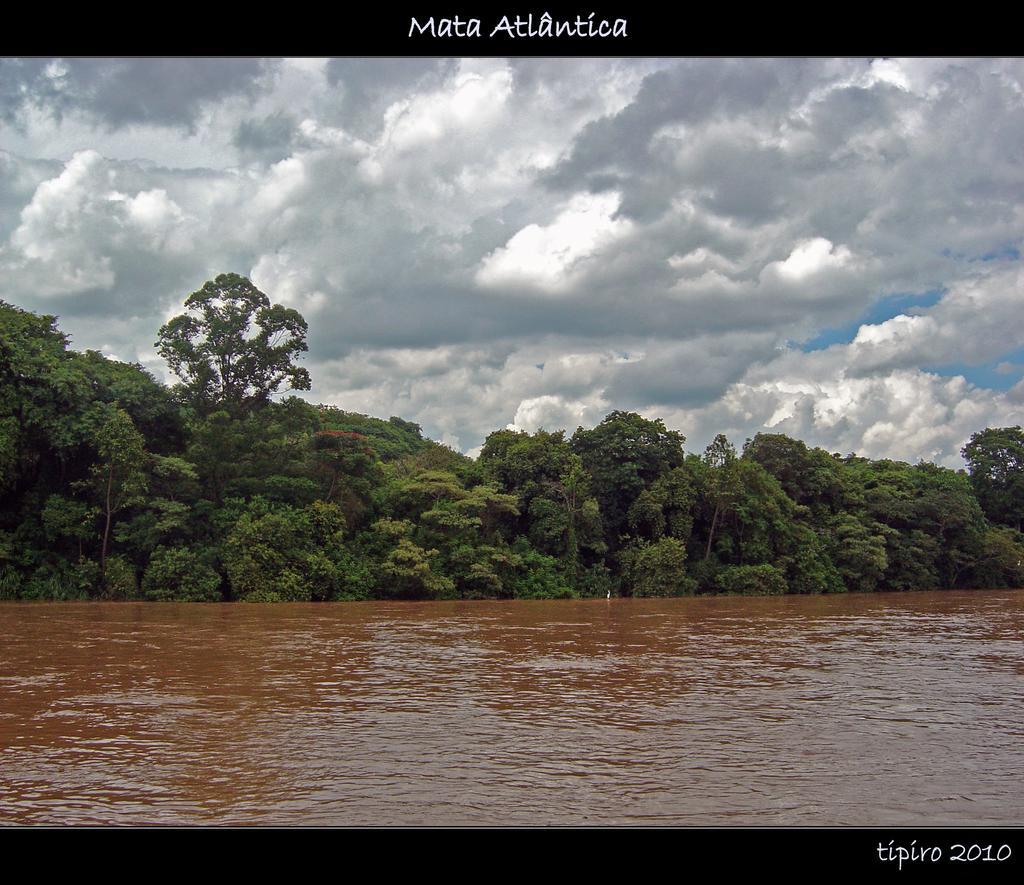Please provide a concise description of this image. In this picture we can see one lake, beside there are so many trees. 